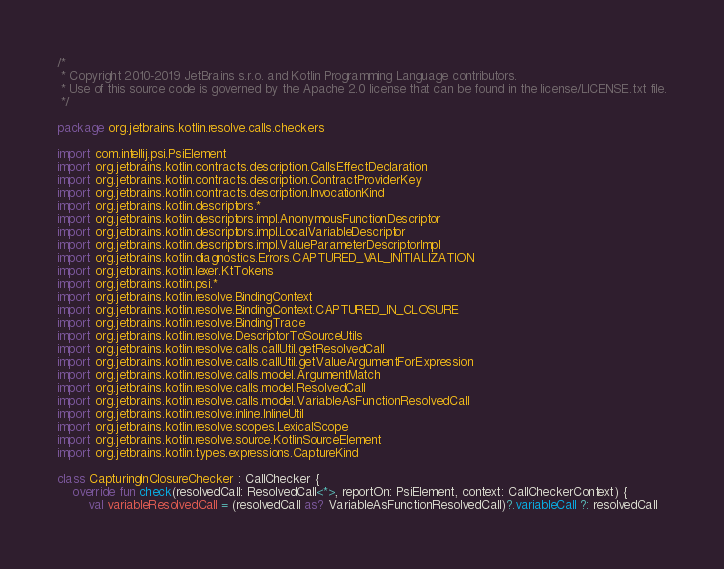<code> <loc_0><loc_0><loc_500><loc_500><_Kotlin_>/*
 * Copyright 2010-2019 JetBrains s.r.o. and Kotlin Programming Language contributors.
 * Use of this source code is governed by the Apache 2.0 license that can be found in the license/LICENSE.txt file.
 */

package org.jetbrains.kotlin.resolve.calls.checkers

import com.intellij.psi.PsiElement
import org.jetbrains.kotlin.contracts.description.CallsEffectDeclaration
import org.jetbrains.kotlin.contracts.description.ContractProviderKey
import org.jetbrains.kotlin.contracts.description.InvocationKind
import org.jetbrains.kotlin.descriptors.*
import org.jetbrains.kotlin.descriptors.impl.AnonymousFunctionDescriptor
import org.jetbrains.kotlin.descriptors.impl.LocalVariableDescriptor
import org.jetbrains.kotlin.descriptors.impl.ValueParameterDescriptorImpl
import org.jetbrains.kotlin.diagnostics.Errors.CAPTURED_VAL_INITIALIZATION
import org.jetbrains.kotlin.lexer.KtTokens
import org.jetbrains.kotlin.psi.*
import org.jetbrains.kotlin.resolve.BindingContext
import org.jetbrains.kotlin.resolve.BindingContext.CAPTURED_IN_CLOSURE
import org.jetbrains.kotlin.resolve.BindingTrace
import org.jetbrains.kotlin.resolve.DescriptorToSourceUtils
import org.jetbrains.kotlin.resolve.calls.callUtil.getResolvedCall
import org.jetbrains.kotlin.resolve.calls.callUtil.getValueArgumentForExpression
import org.jetbrains.kotlin.resolve.calls.model.ArgumentMatch
import org.jetbrains.kotlin.resolve.calls.model.ResolvedCall
import org.jetbrains.kotlin.resolve.calls.model.VariableAsFunctionResolvedCall
import org.jetbrains.kotlin.resolve.inline.InlineUtil
import org.jetbrains.kotlin.resolve.scopes.LexicalScope
import org.jetbrains.kotlin.resolve.source.KotlinSourceElement
import org.jetbrains.kotlin.types.expressions.CaptureKind

class CapturingInClosureChecker : CallChecker {
    override fun check(resolvedCall: ResolvedCall<*>, reportOn: PsiElement, context: CallCheckerContext) {
        val variableResolvedCall = (resolvedCall as? VariableAsFunctionResolvedCall)?.variableCall ?: resolvedCall</code> 